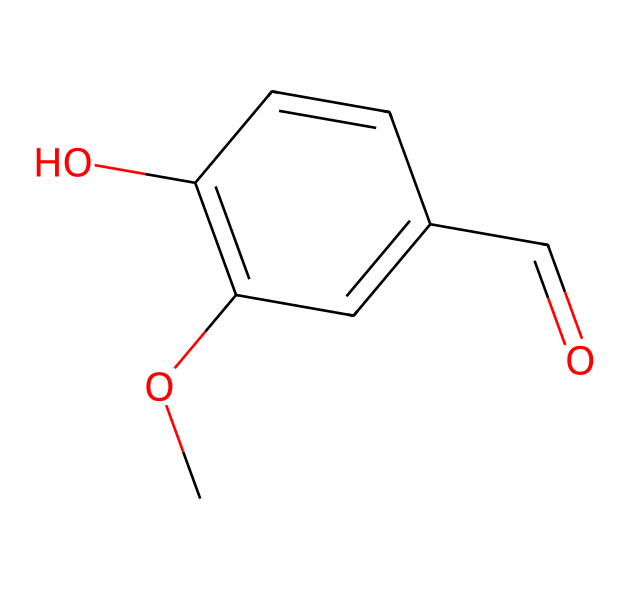What is the name of this aromatic compound? The SMILES representation indicates that this chemical is vanillin, identified by its characteristic functional groups and structure derived from the vanilla bean.
Answer: vanillin How many carbon atoms are present in the molecular structure? By examining the SMILES, we note the 'C' symbols, totaling 8 carbon atoms in the structure.
Answer: 8 What functional group is present in this compound responsible for its aromatic nature? The presence of the 'C1' notation in the SMILES indicates a cyclic structure, with alternating double bonds, characterizing the aromatic ring.
Answer: aromatic ring What specific bond type is found between the carbon and oxygen in the aldehyde group of vanillin? The presence of 'C=O' in the SMILES indicates a double bond between carbon and oxygen, characteristic of an aldehyde functional group.
Answer: double bond How many oxygen atoms are in the molecular structure? The SMILES shows 'O' appears twice, indicating that there are 2 oxygen atoms present in the structure.
Answer: 2 Which part of the structure contributes to the sweet aroma associated with vanillin? The aldehyde functional group ('C=O') along with the hydroxyl group ('-OH') contribute to the characteristic sweet aroma of vanillin.
Answer: aldehyde and hydroxyl groups Is vanillin a saturated or unsaturated compound? The presence of double bonds in the structure, indicated by '=' signs in the SMILES, confirms that vanillin is an unsaturated compound.
Answer: unsaturated 